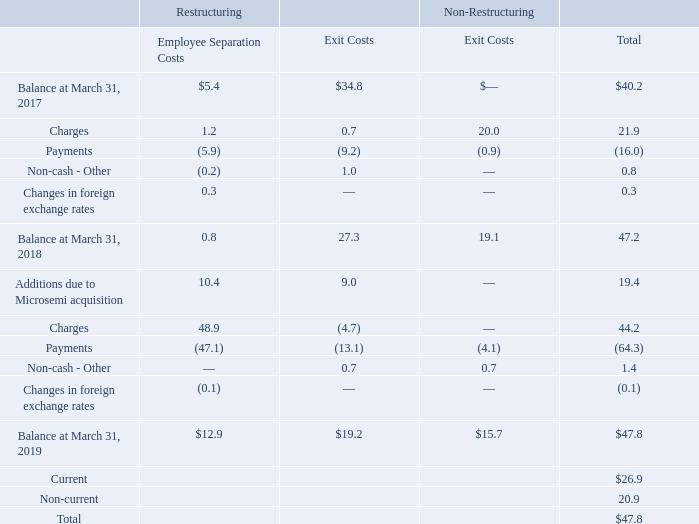The following is a roll forward of accrued restructuring charges for fiscal 2019 and fiscal 2018 (in millions):
The liability for restructuring and other exit costs of $47.8 million is included in accrued liabilities and other long-term liabilities, on the Company's consolidated balance sheets as of March 31, 2019.
What was the liability for restructuring and other exit costs that was included in accrued liabilities and other long-term liabilities as of 2019? $47.8 million. What was the total balance as of 2017?
Answer scale should be: million. 40.2. What were the total Additions due to Microsemi acquisition in 2018?
Answer scale should be: million. 19.4. What was the change in restructuring exit costs for Charges between 2017 and 2018?
Answer scale should be: million. 27.3-0.7
Answer: 26.6. How many years did the total balance exceed $45 million? 2019##2018
Answer: 2. What was the percentage change in the total balance between 2018 and 2019?
Answer scale should be: percent. (47.8-47.2)/47.2
Answer: 1.27. 